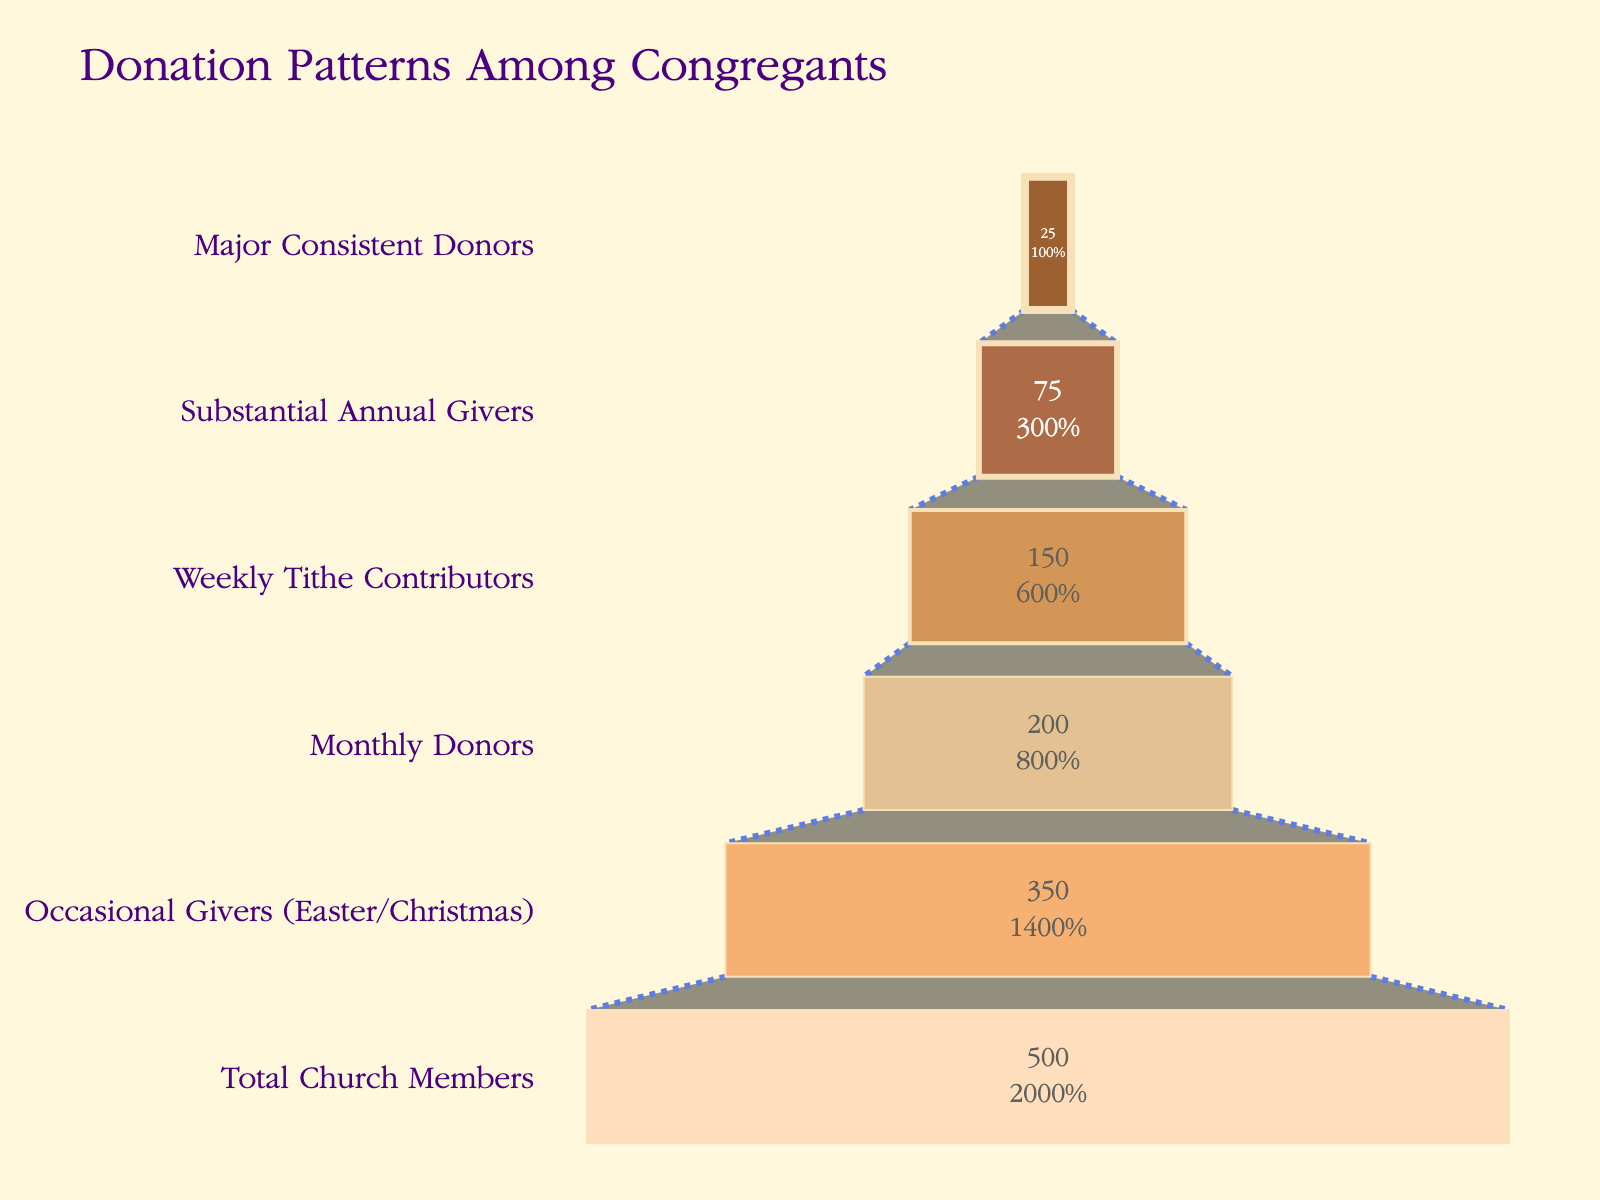what is the title of the chart? The title is always displayed at the top of the chart. In this case, the title says "Donation Patterns Among Congregants" in large, readable font.
Answer: Donation Patterns Among Congregants how many total church members are there? The first stage labeled "Total Church Members" represents the total amount, which is shown as 500 on the chart.
Answer: 500 which group has the smallest number of donors? We look at the bottom of the funnel chart, where the narrowest part is, and see that "Major Consistent Donors" have 25 members.
Answer: Major Consistent Donors what percentage of total church members are occasional givers? The funnel chart shows that there are 350 Occasional Givers. To find the percentage, divide 350 by the total number of church members, 500, and multiply by 100. So, (350 / 500) * 100 = 70%.
Answer: 70% how many more monthly donors are there compared to substantial annual givers? The chart shows 200 Monthly Donors and 75 Substantial Annual Givers. The difference is found by subtracting 75 from 200.
Answer: 125 how many total congregants donate on a monthly or weekly basis? We sum the number of Monthly Donors (200) and Weekly Tithe Contributors (150) from the chart. So, 200 + 150 = 350.
Answer: 350 which stage shows the largest drop in the number of congregants from one stage to the next? We need to find the biggest difference between two consecutive stages. The drop between Occasional Givers (350) and Monthly Donors (200) is 150, which is greater than any other drop.
Answer: Between Occasional Givers and Monthly Donors what percentage of congregants are weekly tithe contributors out of the monthly donors? The funnel chart shows 150 Weekly Tithe Contributors and 200 Monthly Donors. To find the percentage, divide 150 by 200 and multiply by 100. So, (150 / 200) * 100 = 75%.
Answer: 75% if one more major consistent donor is added, how many percent of total church members would that represent? Adding one more to Major Consistent Donors gives 26. To find the percentage, divide 26 by 500 (total church members) and multiply by 100. So, (26 / 500) * 100 = 5.2%.
Answer: 5.2% what is the overall trend depicted in the chart? Each stage of the funnel represents a smaller and more committed group of donors, starting from all church members to the most dedicated donors. The chart visually narrows, indicating that fewer congregants contribute consistently.
Answer: Each stage narrows down to fewer, more committed donors 